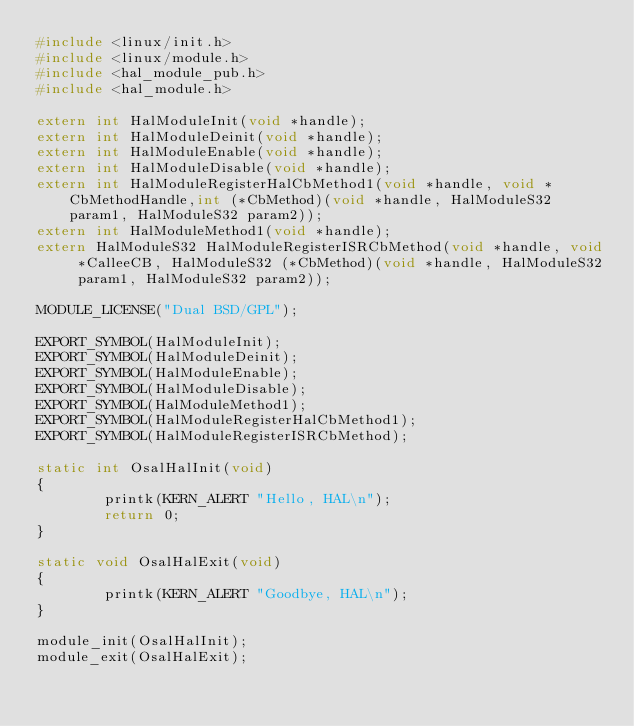<code> <loc_0><loc_0><loc_500><loc_500><_C_>#include <linux/init.h>
#include <linux/module.h>
#include <hal_module_pub.h>
#include <hal_module.h>

extern int HalModuleInit(void *handle);
extern int HalModuleDeinit(void *handle);
extern int HalModuleEnable(void *handle);
extern int HalModuleDisable(void *handle);
extern int HalModuleRegisterHalCbMethod1(void *handle, void *CbMethodHandle,int (*CbMethod)(void *handle, HalModuleS32 param1, HalModuleS32 param2));
extern int HalModuleMethod1(void *handle);
extern HalModuleS32 HalModuleRegisterISRCbMethod(void *handle, void *CalleeCB, HalModuleS32 (*CbMethod)(void *handle, HalModuleS32 param1, HalModuleS32 param2));

MODULE_LICENSE("Dual BSD/GPL");

EXPORT_SYMBOL(HalModuleInit);
EXPORT_SYMBOL(HalModuleDeinit);
EXPORT_SYMBOL(HalModuleEnable);
EXPORT_SYMBOL(HalModuleDisable);
EXPORT_SYMBOL(HalModuleMethod1);
EXPORT_SYMBOL(HalModuleRegisterHalCbMethod1);
EXPORT_SYMBOL(HalModuleRegisterISRCbMethod);

static int OsalHalInit(void)
{
        printk(KERN_ALERT "Hello, HAL\n");
        return 0;
}

static void OsalHalExit(void)
{
        printk(KERN_ALERT "Goodbye, HAL\n");
}

module_init(OsalHalInit);
module_exit(OsalHalExit);
</code> 